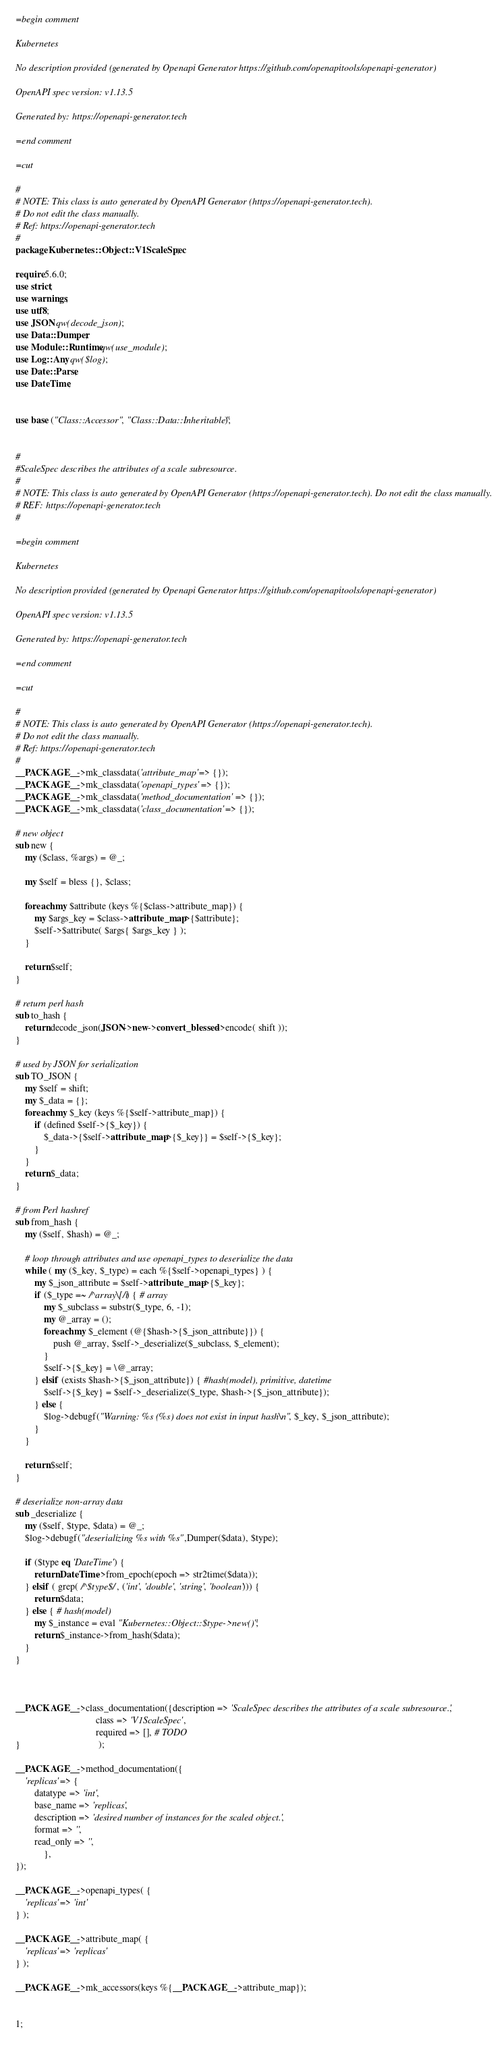Convert code to text. <code><loc_0><loc_0><loc_500><loc_500><_Perl_>=begin comment

Kubernetes

No description provided (generated by Openapi Generator https://github.com/openapitools/openapi-generator)

OpenAPI spec version: v1.13.5

Generated by: https://openapi-generator.tech

=end comment

=cut

#
# NOTE: This class is auto generated by OpenAPI Generator (https://openapi-generator.tech).
# Do not edit the class manually.
# Ref: https://openapi-generator.tech
#
package Kubernetes::Object::V1ScaleSpec;

require 5.6.0;
use strict;
use warnings;
use utf8;
use JSON qw(decode_json);
use Data::Dumper;
use Module::Runtime qw(use_module);
use Log::Any qw($log);
use Date::Parse;
use DateTime;


use base ("Class::Accessor", "Class::Data::Inheritable");


#
#ScaleSpec describes the attributes of a scale subresource.
#
# NOTE: This class is auto generated by OpenAPI Generator (https://openapi-generator.tech). Do not edit the class manually.
# REF: https://openapi-generator.tech
#

=begin comment

Kubernetes

No description provided (generated by Openapi Generator https://github.com/openapitools/openapi-generator)

OpenAPI spec version: v1.13.5

Generated by: https://openapi-generator.tech

=end comment

=cut

#
# NOTE: This class is auto generated by OpenAPI Generator (https://openapi-generator.tech).
# Do not edit the class manually.
# Ref: https://openapi-generator.tech
#
__PACKAGE__->mk_classdata('attribute_map' => {});
__PACKAGE__->mk_classdata('openapi_types' => {});
__PACKAGE__->mk_classdata('method_documentation' => {}); 
__PACKAGE__->mk_classdata('class_documentation' => {});

# new object
sub new { 
    my ($class, %args) = @_; 

	my $self = bless {}, $class;
	
	foreach my $attribute (keys %{$class->attribute_map}) {
		my $args_key = $class->attribute_map->{$attribute};
		$self->$attribute( $args{ $args_key } );
	}
	
	return $self;
}  

# return perl hash
sub to_hash {
    return decode_json(JSON->new->convert_blessed->encode( shift ));
}

# used by JSON for serialization
sub TO_JSON { 
    my $self = shift;
    my $_data = {};
    foreach my $_key (keys %{$self->attribute_map}) {
        if (defined $self->{$_key}) {
            $_data->{$self->attribute_map->{$_key}} = $self->{$_key};
        }
    }
    return $_data;
}

# from Perl hashref
sub from_hash {
    my ($self, $hash) = @_;

    # loop through attributes and use openapi_types to deserialize the data
    while ( my ($_key, $_type) = each %{$self->openapi_types} ) {
    	my $_json_attribute = $self->attribute_map->{$_key}; 
        if ($_type =~ /^array\[/i) { # array
            my $_subclass = substr($_type, 6, -1);
            my @_array = ();
            foreach my $_element (@{$hash->{$_json_attribute}}) {
                push @_array, $self->_deserialize($_subclass, $_element);
            }
            $self->{$_key} = \@_array;
        } elsif (exists $hash->{$_json_attribute}) { #hash(model), primitive, datetime
            $self->{$_key} = $self->_deserialize($_type, $hash->{$_json_attribute});
        } else {
        	$log->debugf("Warning: %s (%s) does not exist in input hash\n", $_key, $_json_attribute);
        }
    }
  
    return $self;
}

# deserialize non-array data
sub _deserialize {
    my ($self, $type, $data) = @_;
    $log->debugf("deserializing %s with %s",Dumper($data), $type);
        
    if ($type eq 'DateTime') {
        return DateTime->from_epoch(epoch => str2time($data));
    } elsif ( grep( /^$type$/, ('int', 'double', 'string', 'boolean'))) {
        return $data;
    } else { # hash(model)
        my $_instance = eval "Kubernetes::Object::$type->new()";
        return $_instance->from_hash($data);
    }
}



__PACKAGE__->class_documentation({description => 'ScaleSpec describes the attributes of a scale subresource.',
                                  class => 'V1ScaleSpec',
                                  required => [], # TODO
}                                 );

__PACKAGE__->method_documentation({
    'replicas' => {
    	datatype => 'int',
    	base_name => 'replicas',
    	description => 'desired number of instances for the scaled object.',
    	format => '',
    	read_only => '',
    		},
});

__PACKAGE__->openapi_types( {
    'replicas' => 'int'
} );

__PACKAGE__->attribute_map( {
    'replicas' => 'replicas'
} );

__PACKAGE__->mk_accessors(keys %{__PACKAGE__->attribute_map});


1;
</code> 